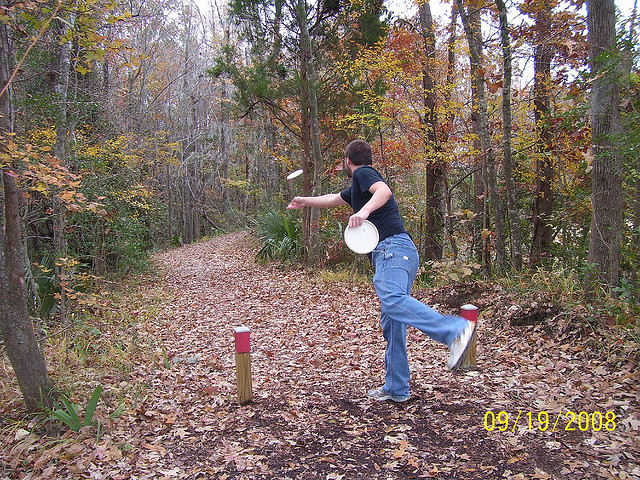Please transcribe the text information in this image. 09/19/2008 